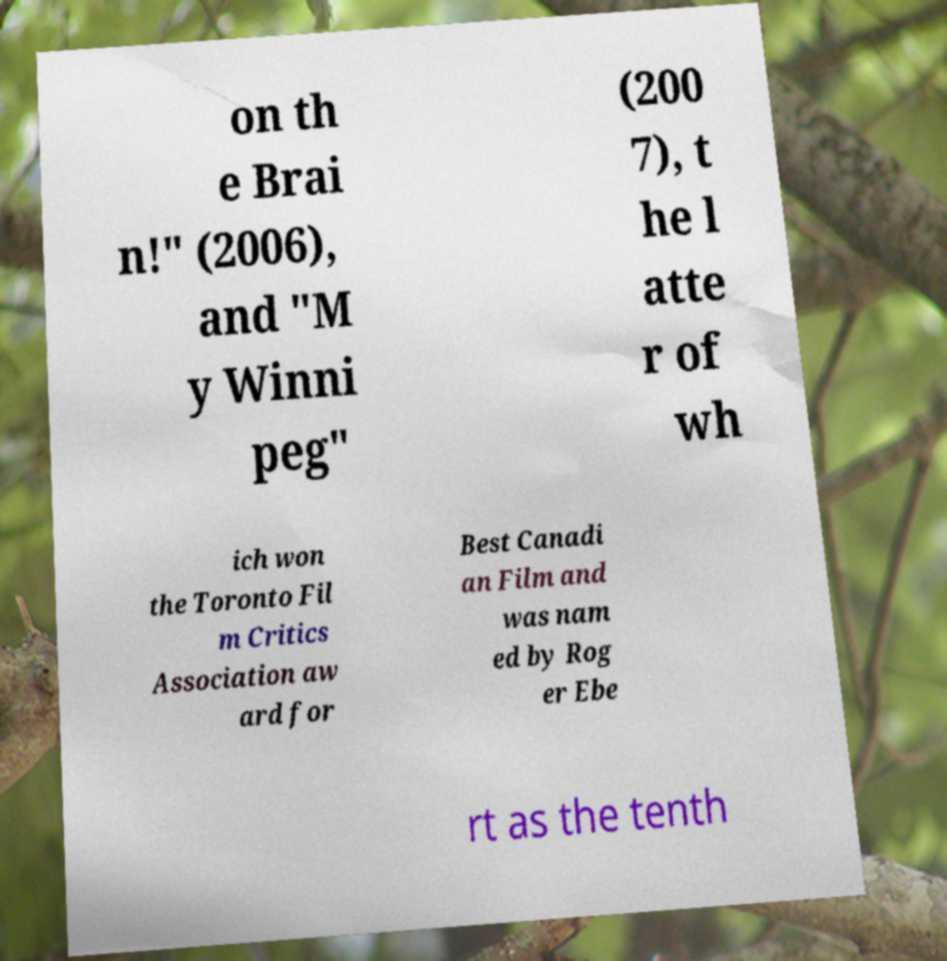There's text embedded in this image that I need extracted. Can you transcribe it verbatim? on th e Brai n!" (2006), and "M y Winni peg" (200 7), t he l atte r of wh ich won the Toronto Fil m Critics Association aw ard for Best Canadi an Film and was nam ed by Rog er Ebe rt as the tenth 